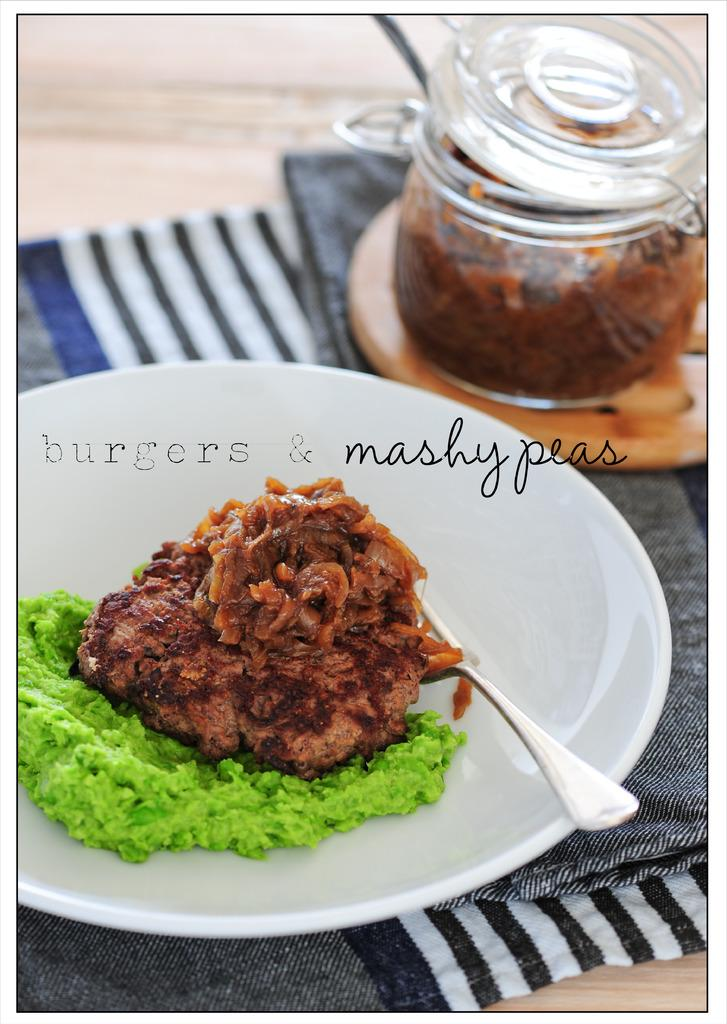What is the main food item visible on the plate in the image? There is a food item on a plate in the image, and it is brown in color. What utensil is present in the image? There is a spoon in the image. What type of container is visible in the image? There is a jar in the image. What is covering the table in the image? There is a cloth on the table in the image. What is the income of the person who owns the cork in the image? There is no cork present in the image, and therefore, we cannot determine the income of any person related to the image. 